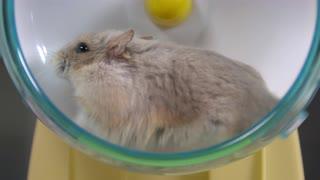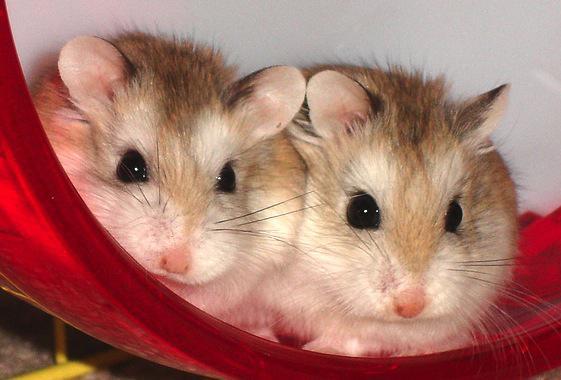The first image is the image on the left, the second image is the image on the right. Assess this claim about the two images: "At least one image shows only one hamster.". Correct or not? Answer yes or no. Yes. The first image is the image on the left, the second image is the image on the right. Considering the images on both sides, is "The images contain a total of four hamsters that are on a plastic object." valid? Answer yes or no. No. 